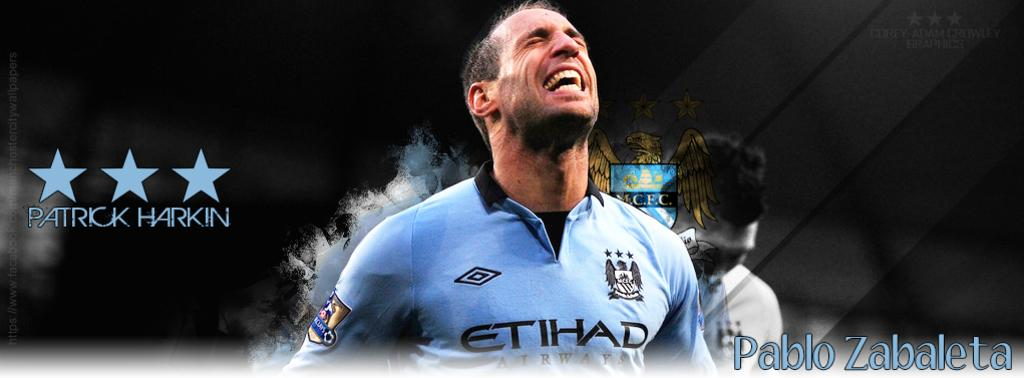<image>
Present a compact description of the photo's key features. A promotional poster showing Pablo Zabaleta of Manchester City FC 